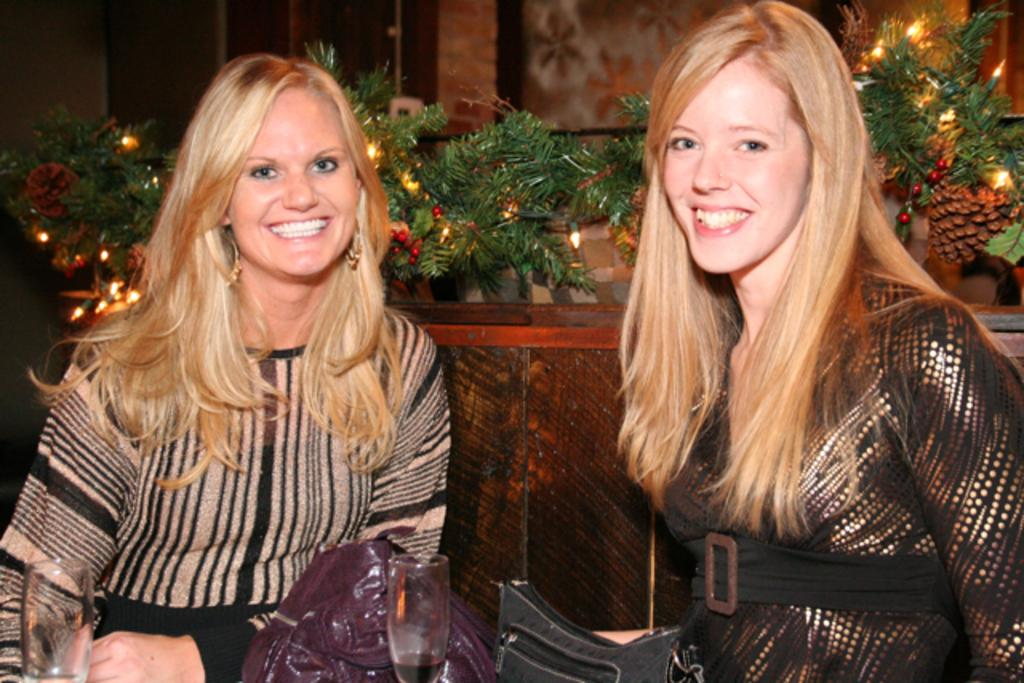How many women are in the image? There are two women in the image. What are the women doing in the image? The women are sitting and posing for a photo. What object can be seen in the image that is typically used for holding liquids? There is a glass in the image. What type of accessory can be seen in the image that is commonly used for carrying personal items? There are handbags in the image. What can be seen in the background of the image that adds a decorative touch? In the background, there are decorative items with lights. Can you tell me how many flowers are in the image? There are no flowers present in the image. What type of dog can be seen in the image? There is no dog present in the image. 